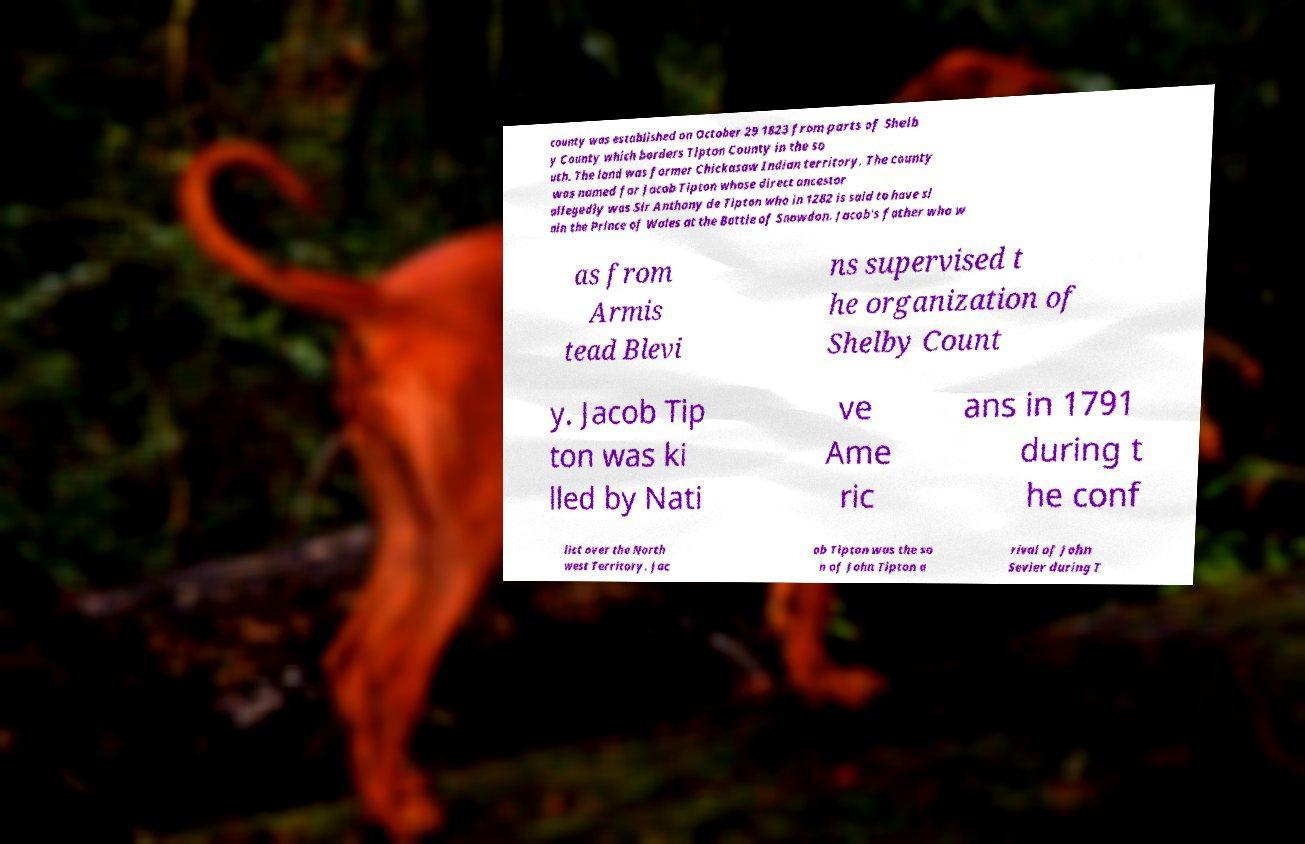Please identify and transcribe the text found in this image. county was established on October 29 1823 from parts of Shelb y County which borders Tipton County in the so uth. The land was former Chickasaw Indian territory. The county was named for Jacob Tipton whose direct ancestor allegedly was Sir Anthony de Tipton who in 1282 is said to have sl ain the Prince of Wales at the Battle of Snowdon. Jacob's father who w as from Armis tead Blevi ns supervised t he organization of Shelby Count y. Jacob Tip ton was ki lled by Nati ve Ame ric ans in 1791 during t he conf lict over the North west Territory. Jac ob Tipton was the so n of John Tipton a rival of John Sevier during T 